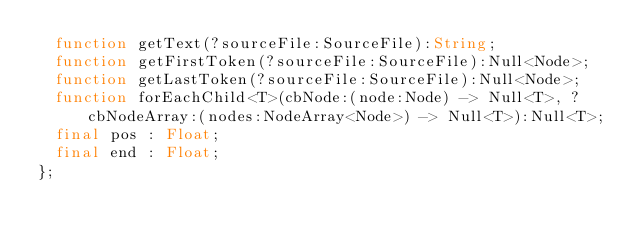Convert code to text. <code><loc_0><loc_0><loc_500><loc_500><_Haxe_>	function getText(?sourceFile:SourceFile):String;
	function getFirstToken(?sourceFile:SourceFile):Null<Node>;
	function getLastToken(?sourceFile:SourceFile):Null<Node>;
	function forEachChild<T>(cbNode:(node:Node) -> Null<T>, ?cbNodeArray:(nodes:NodeArray<Node>) -> Null<T>):Null<T>;
	final pos : Float;
	final end : Float;
};</code> 